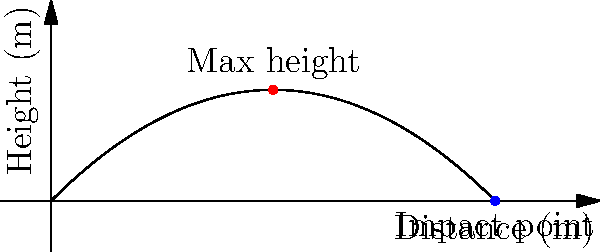A projectile is launched at an initial velocity of 20 m/s at a 45-degree angle. Assuming no air resistance, what is the horizontal distance traveled by the projectile at the point of impact, and how might this information be relevant to assessing potential injury patterns in a trauma case? To solve this problem, we'll follow these steps:

1. Identify the relevant equations:
   - Range equation: $R = \frac{v_0^2 \sin(2\theta)}{g}$
   - Where $v_0$ is the initial velocity, $\theta$ is the launch angle, and $g$ is the acceleration due to gravity (9.8 m/s²)

2. Input the given values:
   $v_0 = 20$ m/s
   $\theta = 45°$
   $g = 9.8$ m/s²

3. Calculate the range:
   $R = \frac{(20 \text{ m/s})^2 \sin(2 \cdot 45°)}{9.8 \text{ m/s}^2}$
   $= \frac{400 \text{ m}^2 \cdot 1}{9.8 \text{ m/s}^2}$
   $= 40.82 \text{ m}$

4. Relevance to injury patterns:
   - The horizontal distance helps determine the impact velocity and energy.
   - A longer range implies higher impact energy, potentially causing more severe injuries.
   - The trajectory information can help predict the likely point of impact on the body.
   - Understanding the projectile's path aids in assessing potential internal organ damage.
   - This data can guide triage decisions and resource allocation in trauma care.
Answer: 40.82 m; aids in predicting impact energy, likely body impact point, and potential internal injuries. 